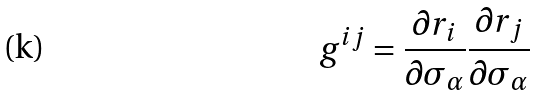Convert formula to latex. <formula><loc_0><loc_0><loc_500><loc_500>g ^ { i j } = \frac { \partial r _ { i } } { \partial \sigma _ { \alpha } } \frac { \partial r _ { j } } { \partial \sigma _ { \alpha } }</formula> 